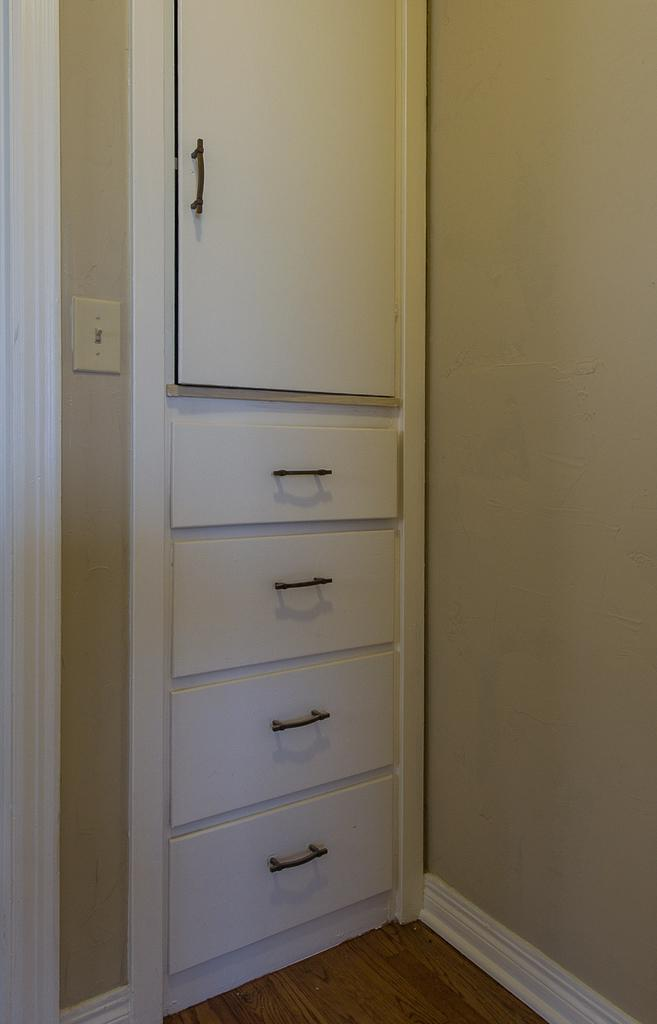What type of furniture is present in the image? There is a cupboard in the image. What else can be seen in the image besides the cupboard? There is a wall visible in the image. Can you see any snails crawling on the wall in the image? There are no snails visible on the wall in the image. What type of sand is used to fill the cupboard in the image? There is no sand present in the image, and the cupboard is not filled with sand. 